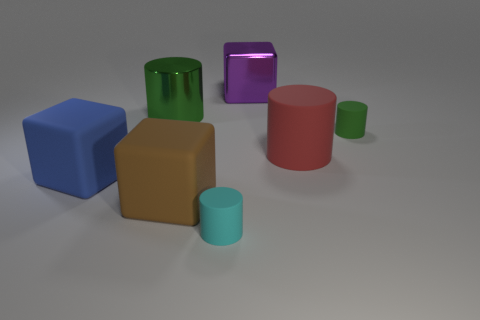What number of things are matte cylinders that are in front of the blue matte thing or large cylinders behind the small green matte object?
Offer a very short reply. 2. Does the shiny block have the same color as the large shiny cylinder?
Provide a succinct answer. No. Are there fewer purple things than purple spheres?
Keep it short and to the point. No. There is a big blue rubber object; are there any purple cubes in front of it?
Make the answer very short. No. Does the large green object have the same material as the brown cube?
Your response must be concise. No. There is another big thing that is the same shape as the big red matte thing; what is its color?
Give a very brief answer. Green. Is the color of the tiny cylinder in front of the small green cylinder the same as the metallic cylinder?
Offer a terse response. No. What shape is the small rubber thing that is the same color as the metal cylinder?
Offer a very short reply. Cylinder. What number of other brown blocks are made of the same material as the brown block?
Your answer should be very brief. 0. There is a brown object; how many green cylinders are behind it?
Provide a short and direct response. 2. 